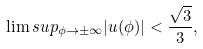<formula> <loc_0><loc_0><loc_500><loc_500>\lim s u p _ { \phi \to \pm \infty } | u ( \phi ) | < \frac { \sqrt { 3 } } 3 ,</formula> 